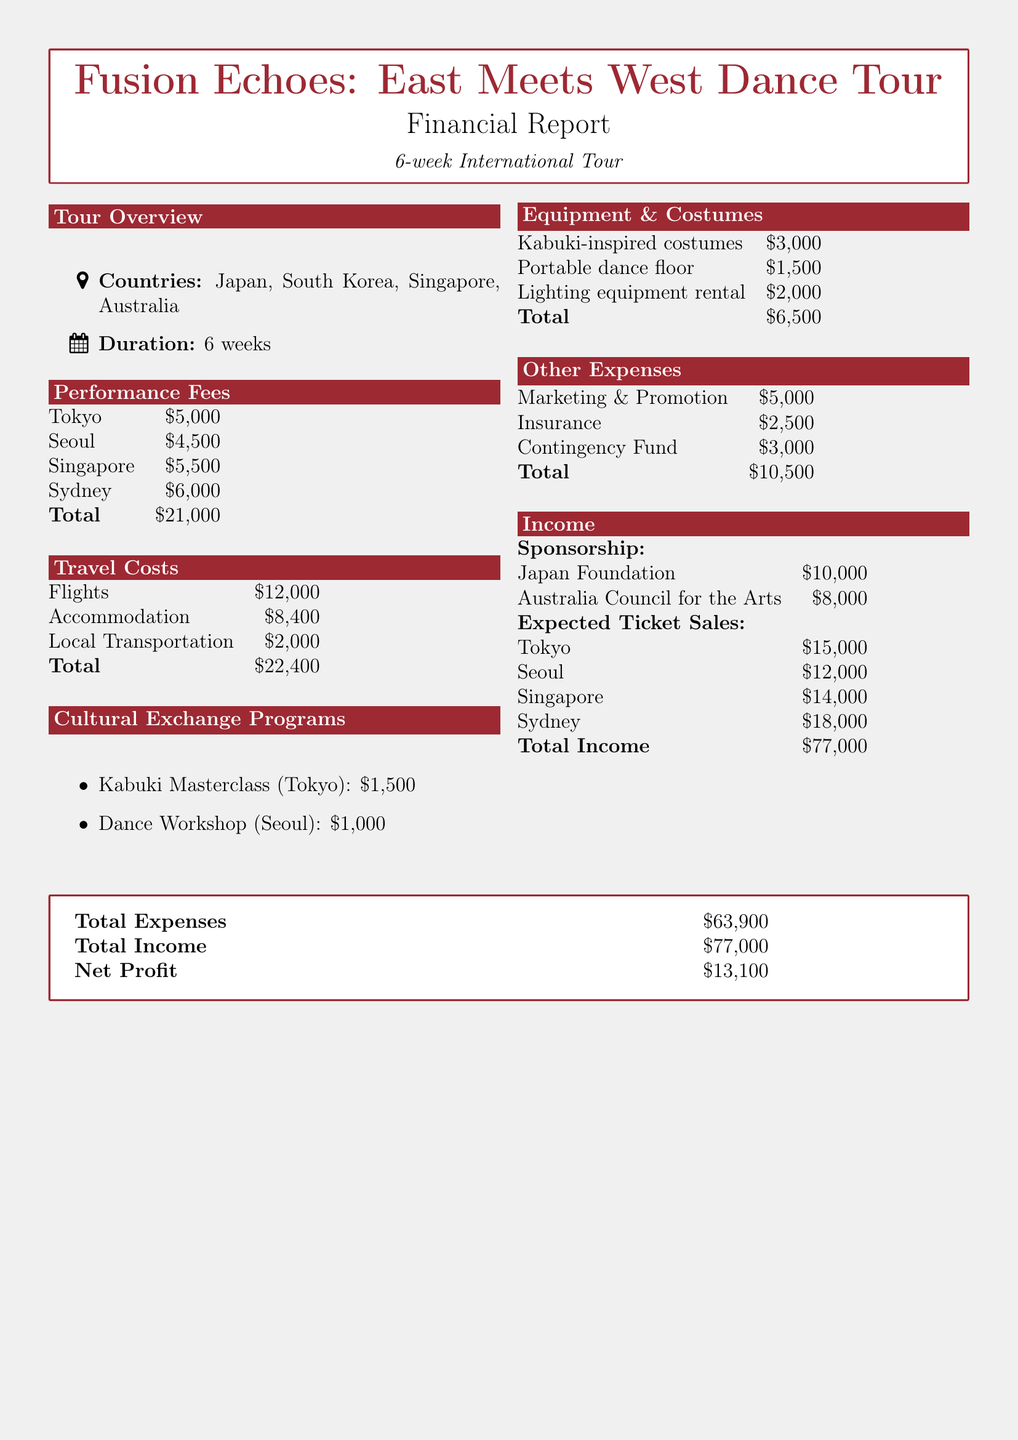what is the duration of the tour? The duration of the tour is mentioned in the overview section of the document.
Answer: 6 weeks what is the total performance fee for all cities? The total performance fee is the sum of fees listed for each city's performance.
Answer: $21,000 how much will local transportation cost? The local transportation cost is outlined in the travel costs.
Answer: $2,000 what is the cost of the Kabuki Masterclass? The price for the Kabuki Masterclass is specified in the cultural exchange programs section.
Answer: $1,500 what is the total cost of equipment and costumes? This total is the sum of the individual costs mentioned for equipment and costumes.
Answer: $6,500 what is the amount sponsored by the Japan Foundation? The sponsorship amount from the Japan Foundation is clearly stated in the income section.
Answer: $10,000 what is the expected ticket sales revenue for Singapore? The expected ticket sales for Singapore is provided in the income section.
Answer: $14,000 what is the total income from expected ticket sales? This figure is derived by adding up the expected ticket sales from all cities in the document.
Answer: $59,000 what is the net profit from the tour? The net profit is calculated by subtracting the total expenses from the total income reported.
Answer: $13,100 